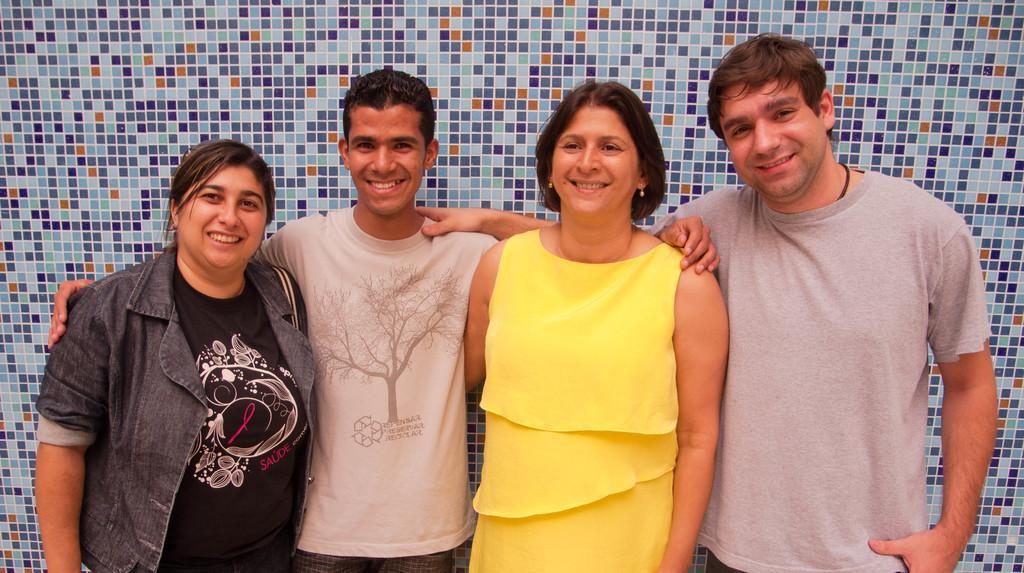Can you describe this image briefly? In this image in front there are four people wearing a smile on their faces. Behind them there is a wall. 